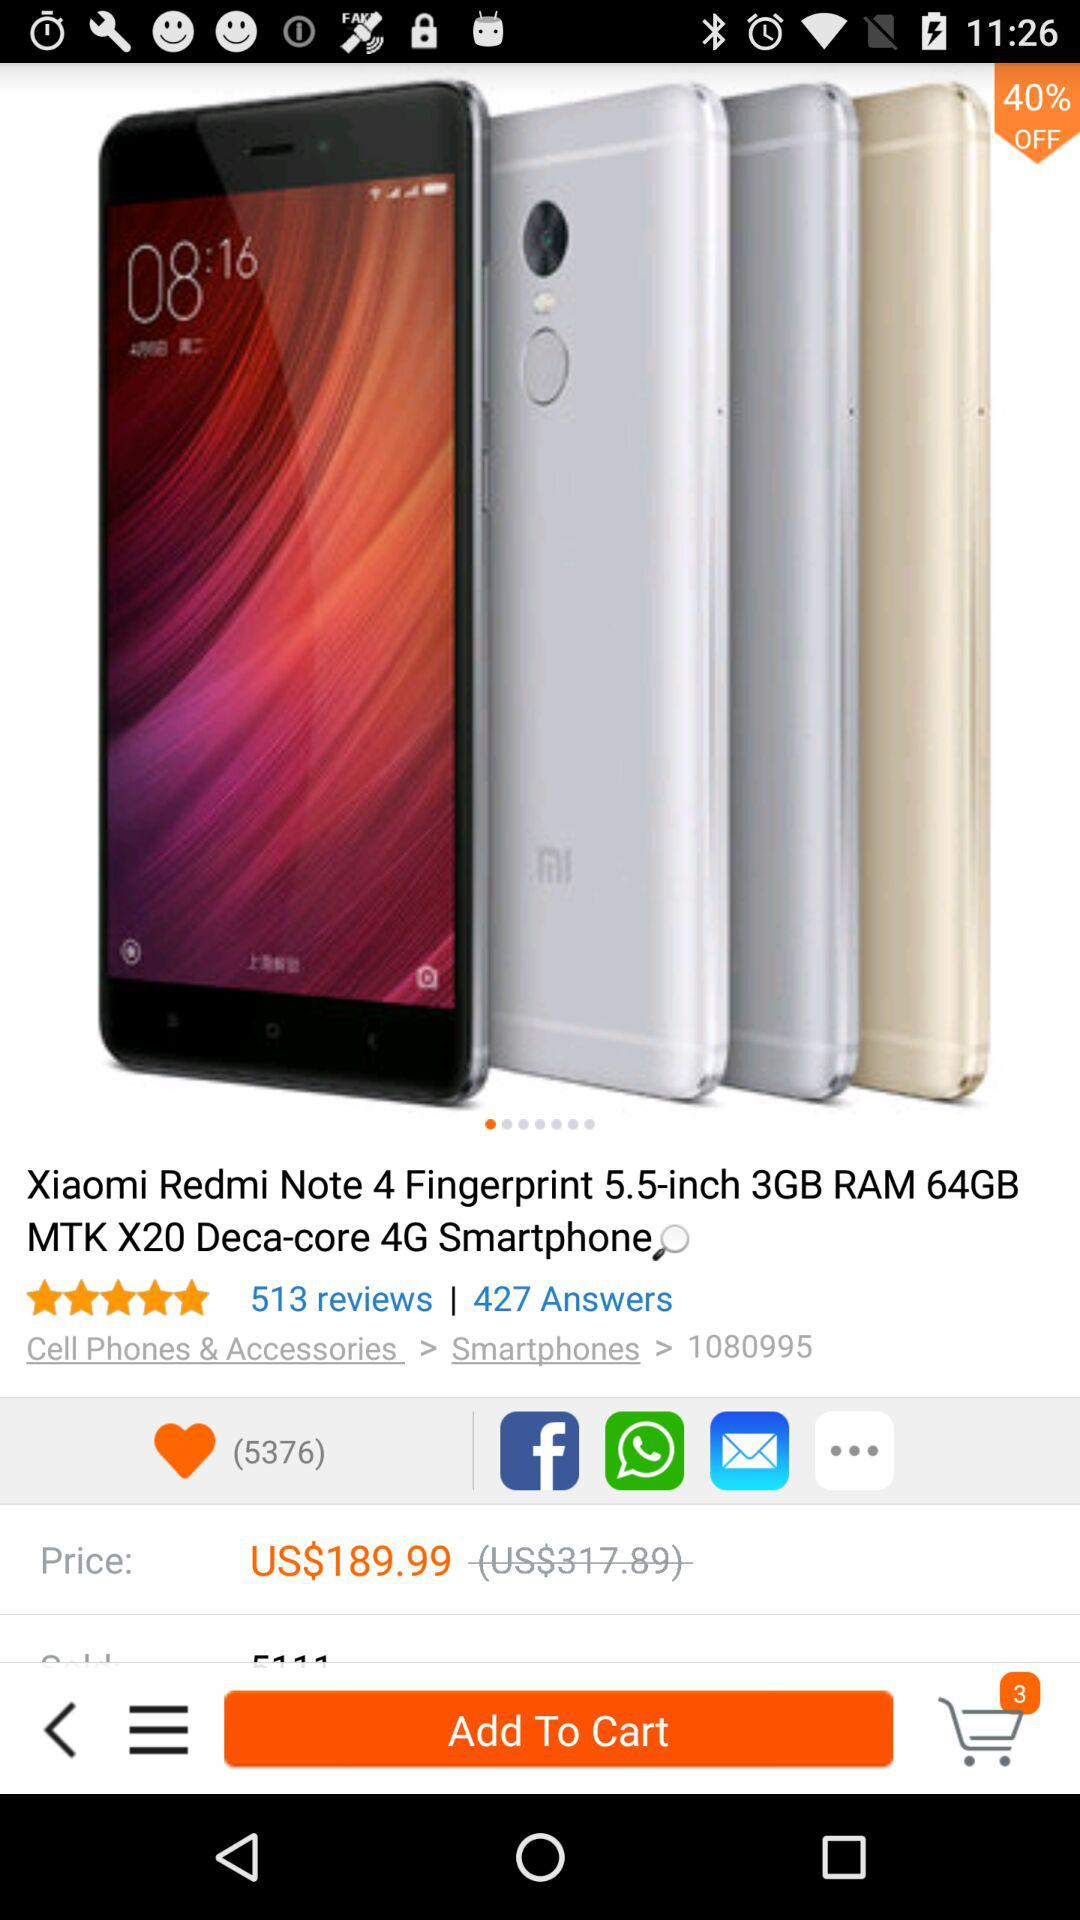How many likes has the "Xiaomi Redmi Note 4" received? The "Xiaomi Redmi Note 4" has received 5376 likes. 